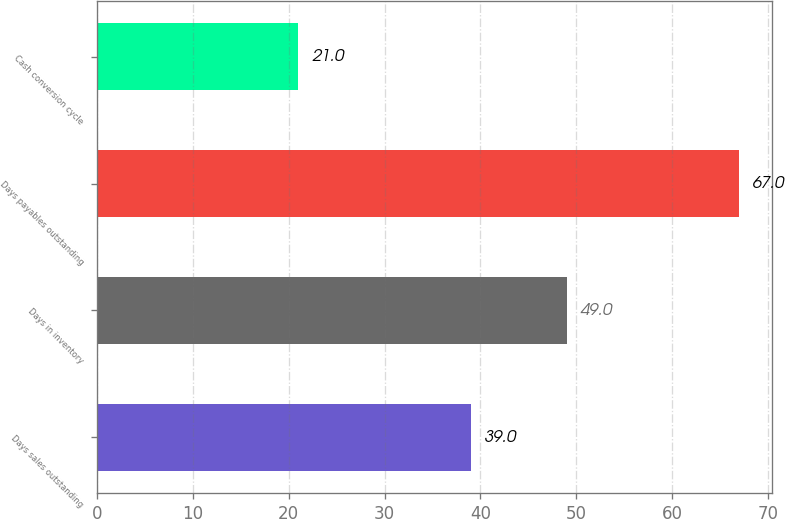<chart> <loc_0><loc_0><loc_500><loc_500><bar_chart><fcel>Days sales outstanding<fcel>Days in inventory<fcel>Days payables outstanding<fcel>Cash conversion cycle<nl><fcel>39<fcel>49<fcel>67<fcel>21<nl></chart> 